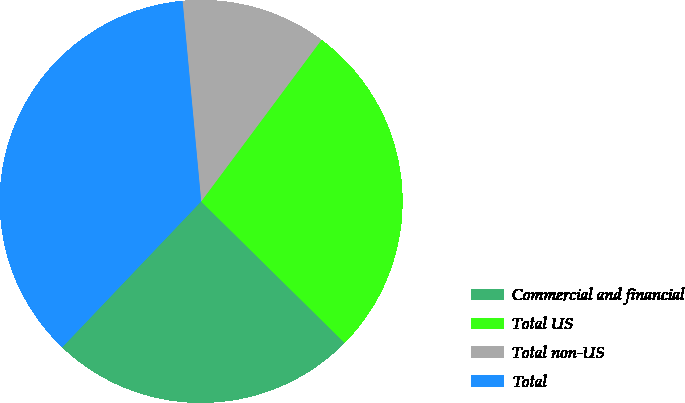<chart> <loc_0><loc_0><loc_500><loc_500><pie_chart><fcel>Commercial and financial<fcel>Total US<fcel>Total non-US<fcel>Total<nl><fcel>24.73%<fcel>27.2%<fcel>11.66%<fcel>36.41%<nl></chart> 